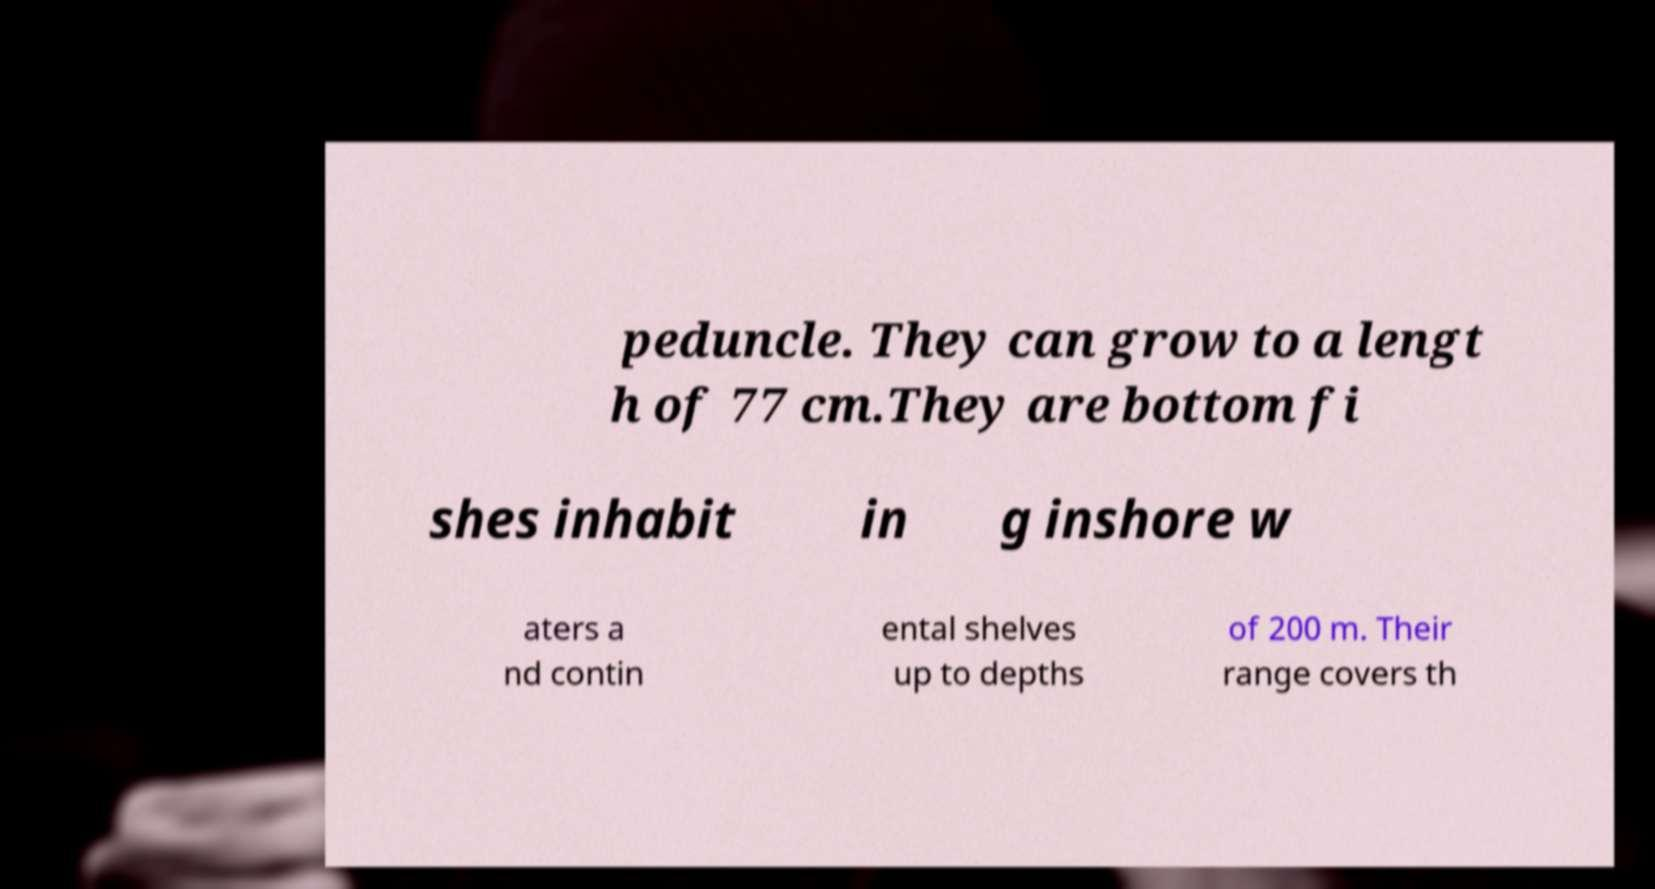Can you read and provide the text displayed in the image?This photo seems to have some interesting text. Can you extract and type it out for me? peduncle. They can grow to a lengt h of 77 cm.They are bottom fi shes inhabit in g inshore w aters a nd contin ental shelves up to depths of 200 m. Their range covers th 